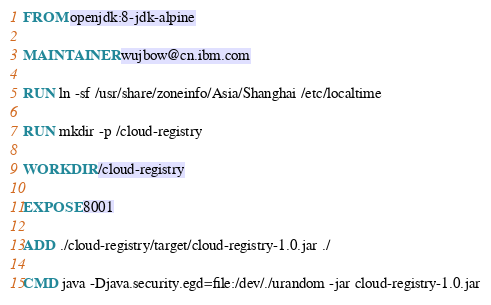Convert code to text. <code><loc_0><loc_0><loc_500><loc_500><_Dockerfile_>FROM openjdk:8-jdk-alpine

MAINTAINER wujbow@cn.ibm.com

RUN ln -sf /usr/share/zoneinfo/Asia/Shanghai /etc/localtime

RUN mkdir -p /cloud-registry

WORKDIR /cloud-registry

EXPOSE 8001

ADD ./cloud-registry/target/cloud-registry-1.0.jar ./

CMD java -Djava.security.egd=file:/dev/./urandom -jar cloud-registry-1.0.jar
</code> 